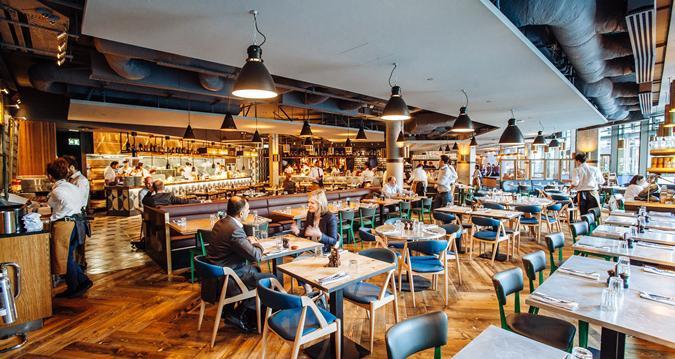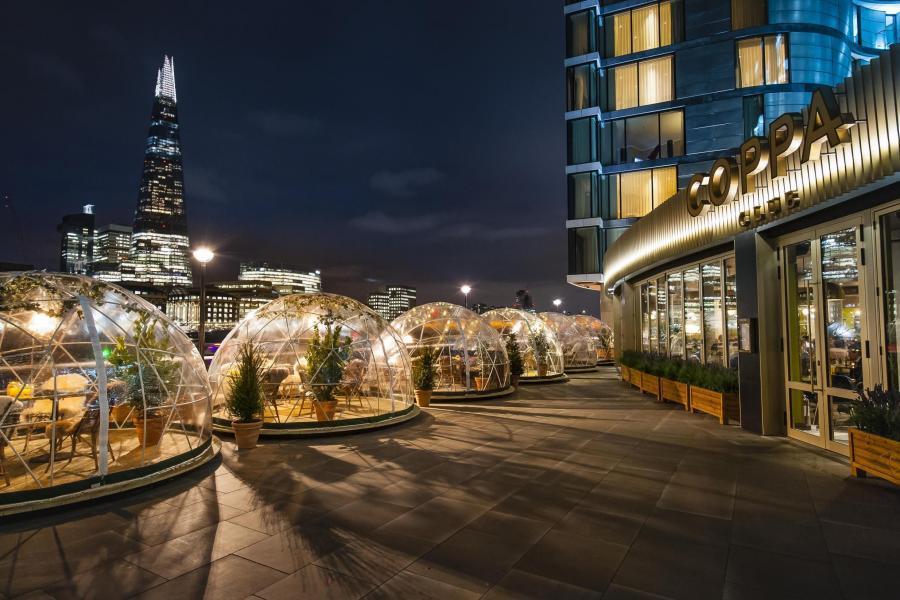The first image is the image on the left, the second image is the image on the right. For the images shown, is this caption "The right image shows an open-air rooftop dining area with a background of a span bridge featuring two square columns with castle-like tops." true? Answer yes or no. No. 